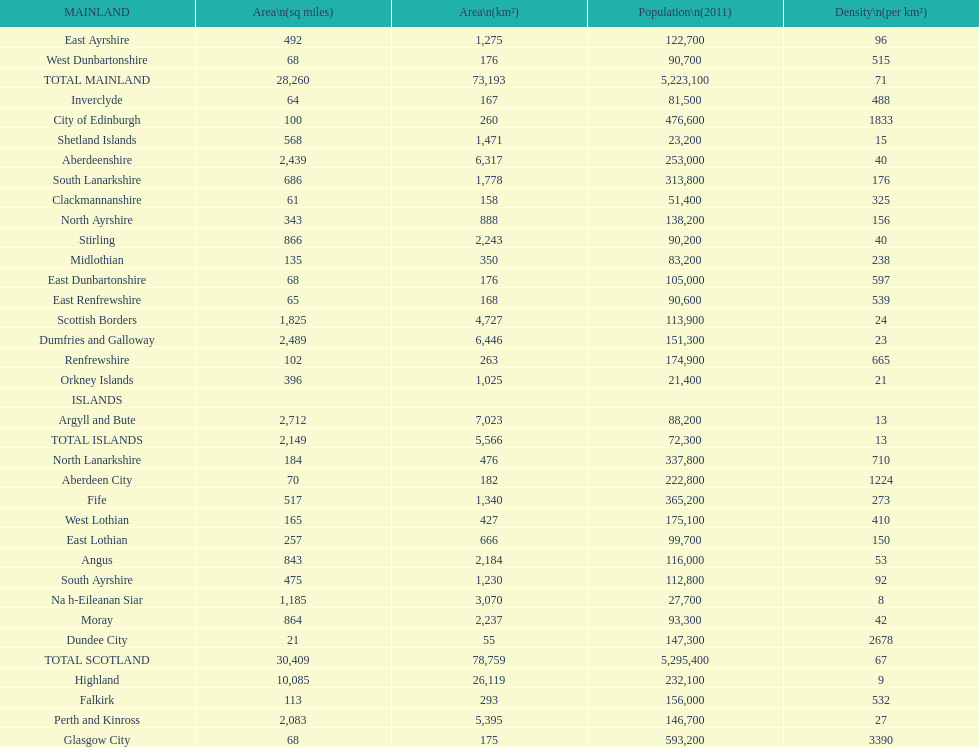What is the difference in square miles between angus and fife? 326. Would you be able to parse every entry in this table? {'header': ['MAINLAND', 'Area\\n(sq miles)', 'Area\\n(km²)', 'Population\\n(2011)', 'Density\\n(per km²)'], 'rows': [['East Ayrshire', '492', '1,275', '122,700', '96'], ['West Dunbartonshire', '68', '176', '90,700', '515'], ['TOTAL MAINLAND', '28,260', '73,193', '5,223,100', '71'], ['Inverclyde', '64', '167', '81,500', '488'], ['City of Edinburgh', '100', '260', '476,600', '1833'], ['Shetland Islands', '568', '1,471', '23,200', '15'], ['Aberdeenshire', '2,439', '6,317', '253,000', '40'], ['South Lanarkshire', '686', '1,778', '313,800', '176'], ['Clackmannanshire', '61', '158', '51,400', '325'], ['North Ayrshire', '343', '888', '138,200', '156'], ['Stirling', '866', '2,243', '90,200', '40'], ['Midlothian', '135', '350', '83,200', '238'], ['East Dunbartonshire', '68', '176', '105,000', '597'], ['East Renfrewshire', '65', '168', '90,600', '539'], ['Scottish Borders', '1,825', '4,727', '113,900', '24'], ['Dumfries and Galloway', '2,489', '6,446', '151,300', '23'], ['Renfrewshire', '102', '263', '174,900', '665'], ['Orkney Islands', '396', '1,025', '21,400', '21'], ['ISLANDS', '', '', '', ''], ['Argyll and Bute', '2,712', '7,023', '88,200', '13'], ['TOTAL ISLANDS', '2,149', '5,566', '72,300', '13'], ['North Lanarkshire', '184', '476', '337,800', '710'], ['Aberdeen City', '70', '182', '222,800', '1224'], ['Fife', '517', '1,340', '365,200', '273'], ['West Lothian', '165', '427', '175,100', '410'], ['East Lothian', '257', '666', '99,700', '150'], ['Angus', '843', '2,184', '116,000', '53'], ['South Ayrshire', '475', '1,230', '112,800', '92'], ['Na h-Eileanan Siar', '1,185', '3,070', '27,700', '8'], ['Moray', '864', '2,237', '93,300', '42'], ['Dundee City', '21', '55', '147,300', '2678'], ['TOTAL SCOTLAND', '30,409', '78,759', '5,295,400', '67'], ['Highland', '10,085', '26,119', '232,100', '9'], ['Falkirk', '113', '293', '156,000', '532'], ['Perth and Kinross', '2,083', '5,395', '146,700', '27'], ['Glasgow City', '68', '175', '593,200', '3390']]} 